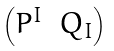Convert formula to latex. <formula><loc_0><loc_0><loc_500><loc_500>\begin{pmatrix} P ^ { I } & Q _ { I } \end{pmatrix}</formula> 